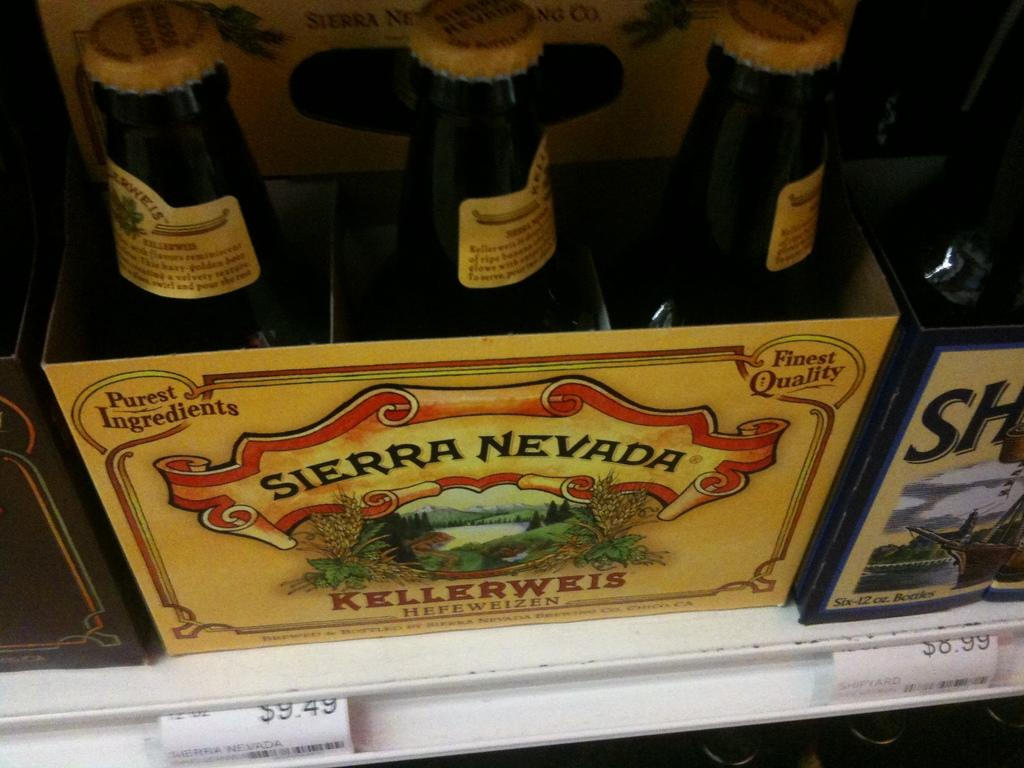<image>
Write a terse but informative summary of the picture. Thre bottles of beer sit in a box labelled Sierra Nevada Kellerweis which has a country scene on it as well. 